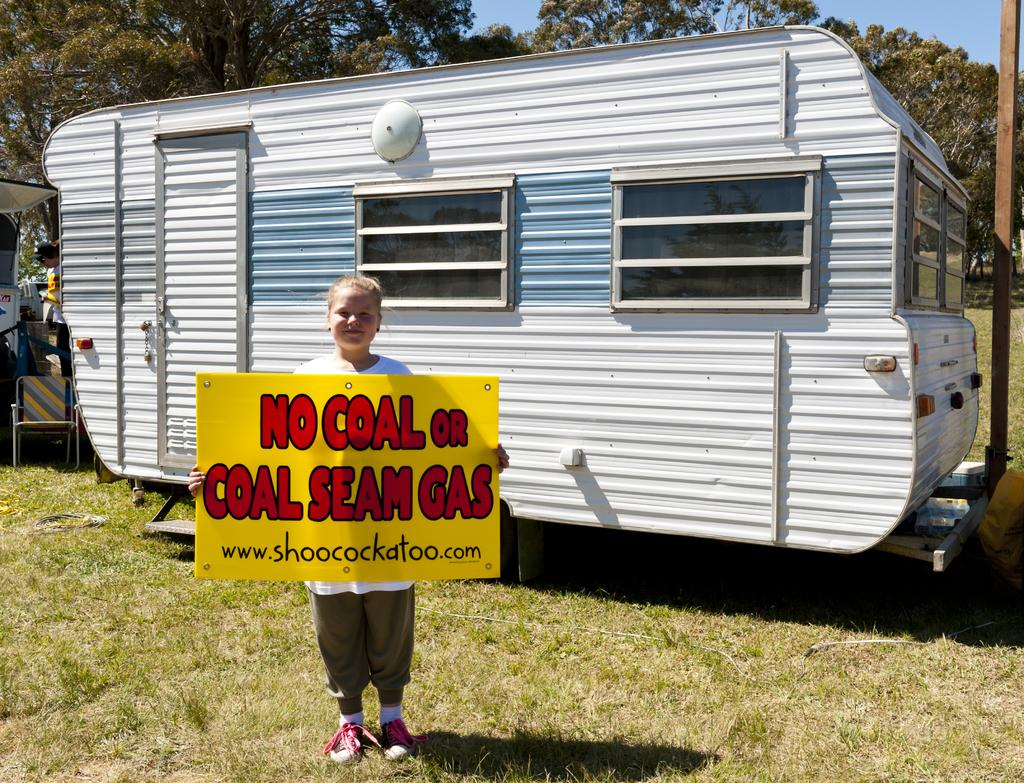Who is the main subject in the image? There is a girl in the image. What is the girl holding in the image? The girl is holding a placard. What type of vehicle can be seen in the image? There is an iron vehicle in the image. What can be seen in the background of the image? Trees are present in the background of the image. What type of ball is being used to create the fog in the image? There is no ball or fog present in the image. What message does the girl's placard convey about hate? The provided facts do not mention any message on the placard, nor do they mention anything about hate. 